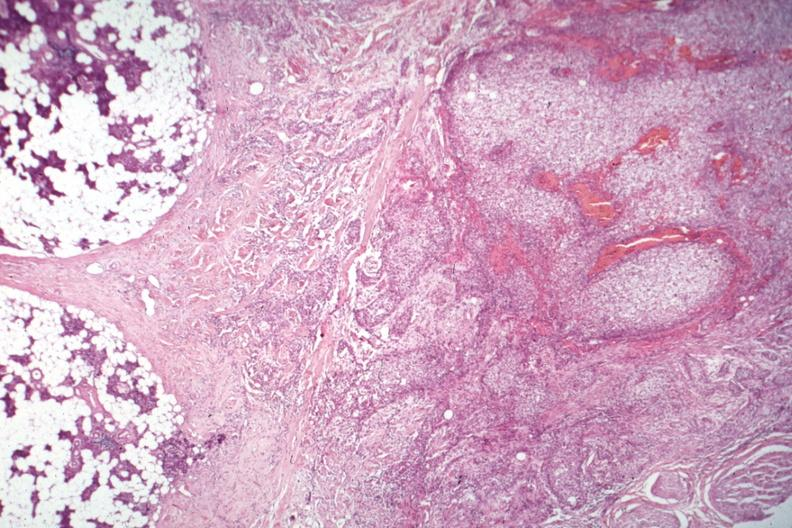s mucoepidermoid carcinoma present?
Answer the question using a single word or phrase. Yes 